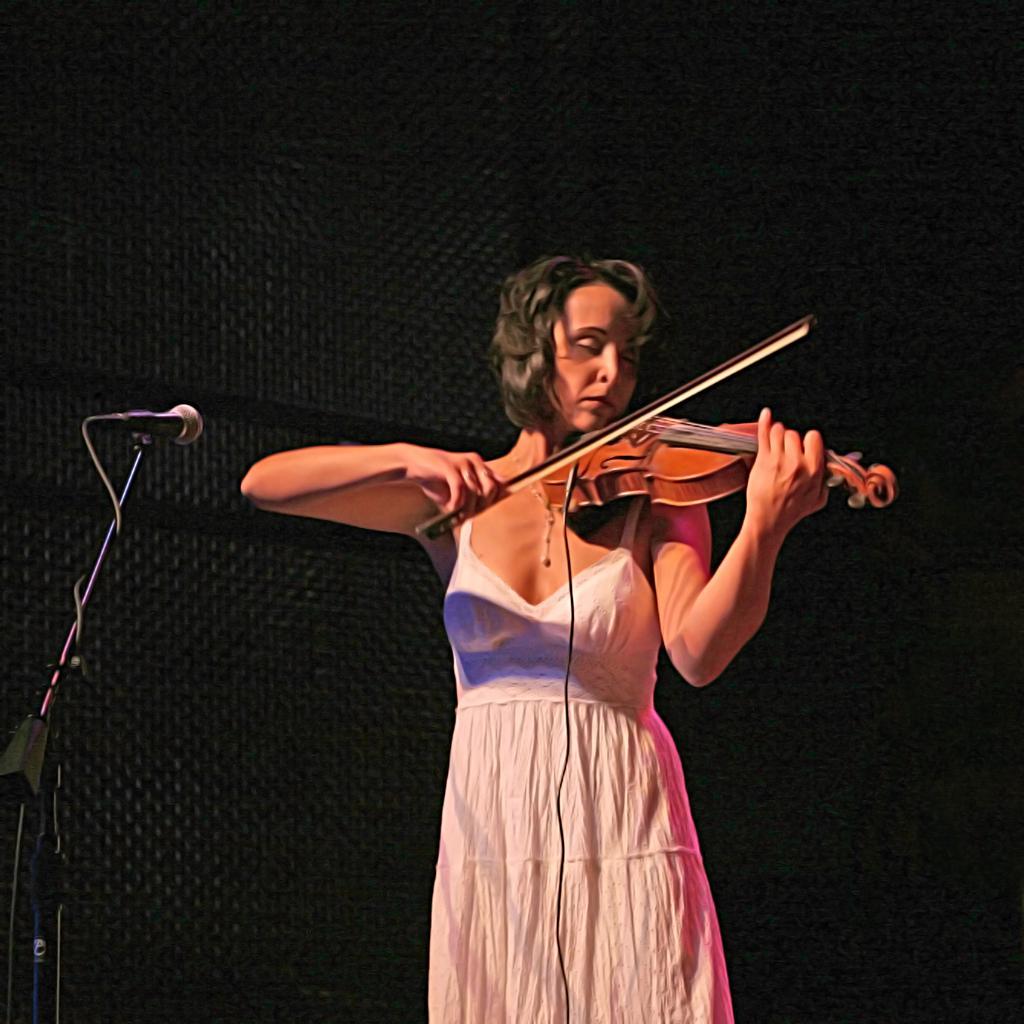Could you give a brief overview of what you see in this image? In this picture there is a women in white dress is holding a guitar and playing it in front of the mic. 